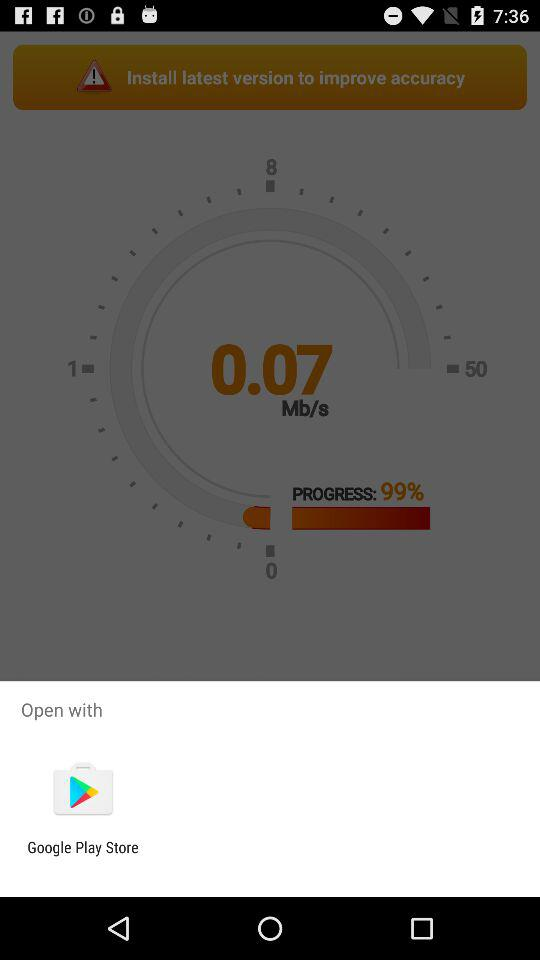With what app can we open it? We can open it with the "Google Play Store". 